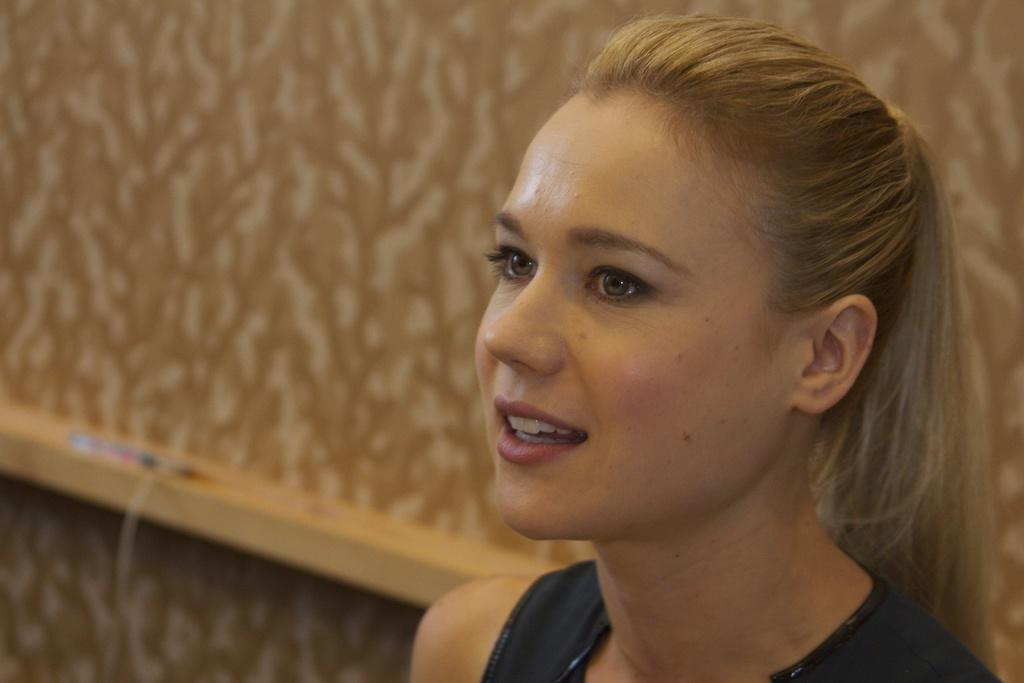What is the main subject of the image? There is a woman in the image. What is the woman wearing? The woman is wearing a black dress. What is the color of the woman's hair? The woman has cream-colored hair. What expression does the woman have? The woman is smiling. What color is the wall in the background of the image? There is a cream-colored wall in the background of the image. How many words can be seen in the woman's eyes in the image? There are no words visible in the woman's eyes in the image. What type of trip is the woman planning based on the image? There is no indication of a trip in the image; it only shows a woman smiling in front of a cream-colored wall. 